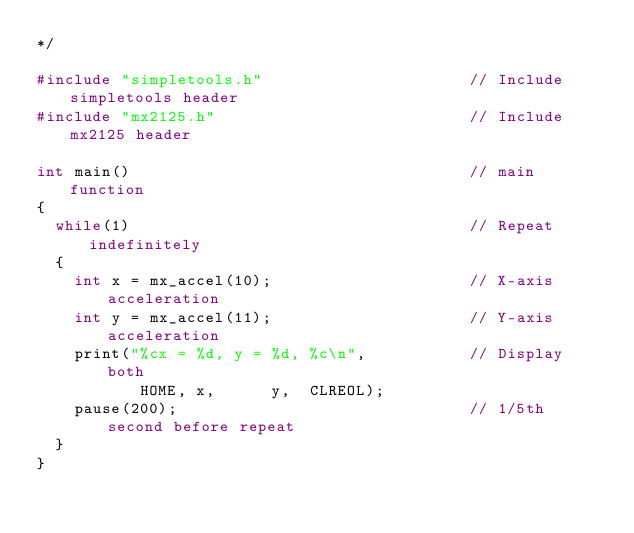Convert code to text. <code><loc_0><loc_0><loc_500><loc_500><_C_>*/

#include "simpletools.h"                      // Include simpletools header
#include "mx2125.h"                           // Include mx2125 header 

int main()                                    // main function
{
  while(1)                                    // Repeat indefinitely
  {
    int x = mx_accel(10);                     // X-axis acceleration 
    int y = mx_accel(11);                     // Y-axis acceleration
    print("%cx = %d, y = %d, %c\n",           // Display both
           HOME, x,      y,  CLREOL);
    pause(200);                               // 1/5th second before repeat
  }  
}

</code> 